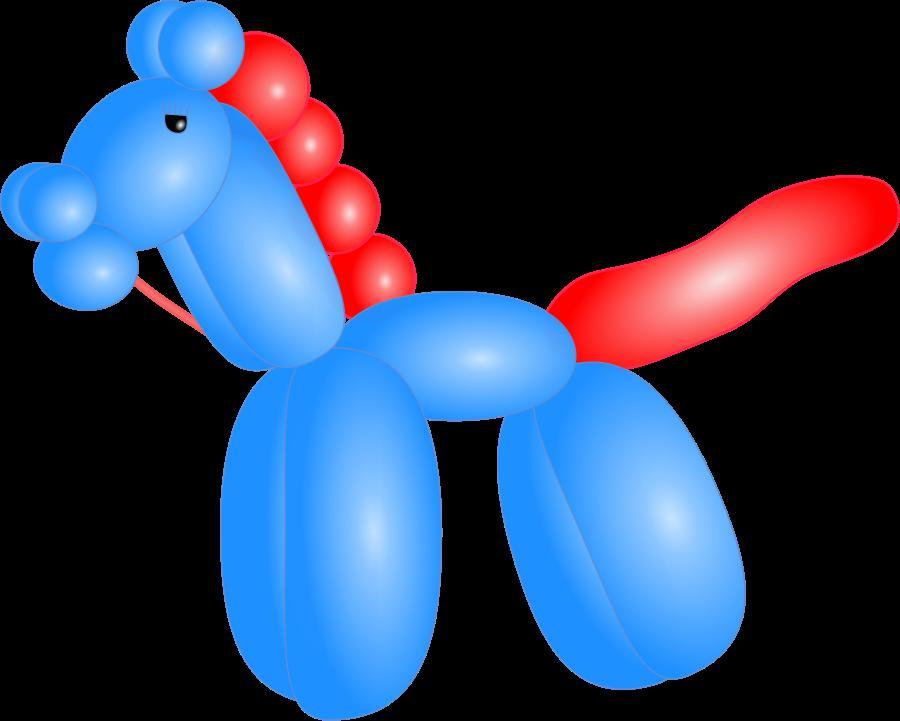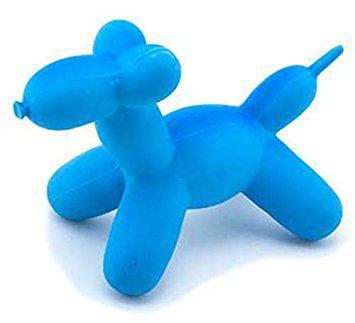The first image is the image on the left, the second image is the image on the right. Assess this claim about the two images: "there is one blue balloon in a shape of a dog facing left". Correct or not? Answer yes or no. Yes. 